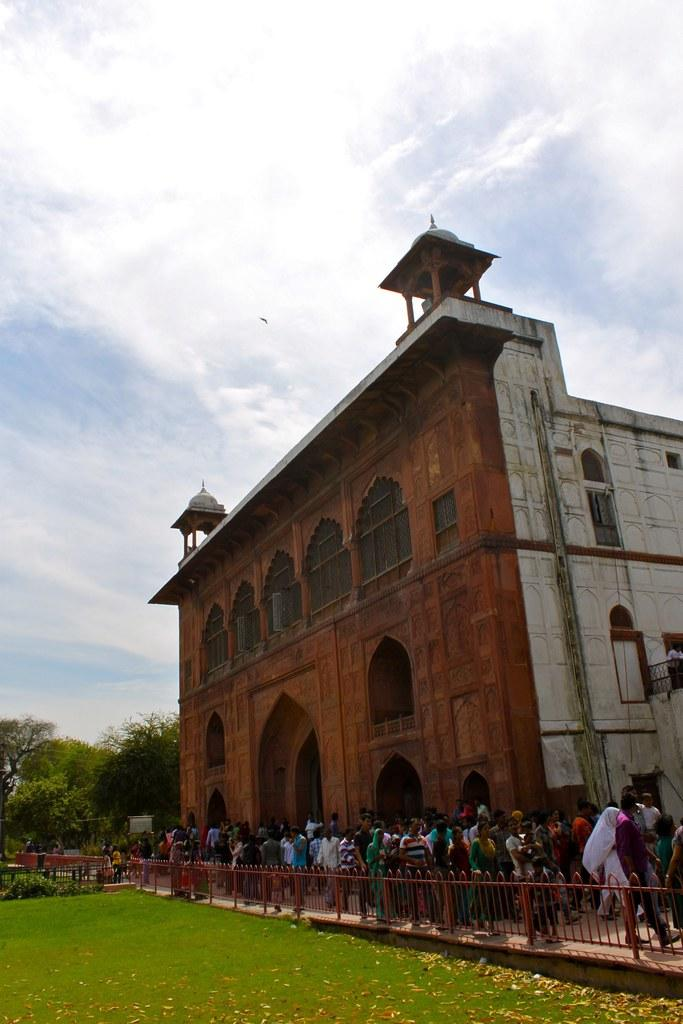What type of structure is visible in the image? There is a building in the image. What are the people in the image doing? There is a group of people walking on the ground in the image. What type of vegetation can be seen in the image? There are trees and grass in the image. What is the condition of the sky in the image? The sky is cloudy in the image. What scientific substance is being used by the people in the image? There is no indication of any scientific substance being used in the image; it simply shows a group of people walking on the ground. What operation is being performed by the trees in the image? Trees are not performing any operation in the image; they are simply part of the natural landscape. 